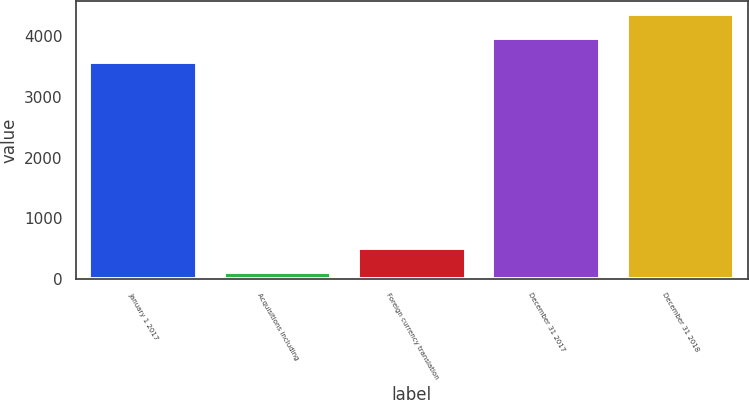<chart> <loc_0><loc_0><loc_500><loc_500><bar_chart><fcel>January 1 2017<fcel>Acquisitions including<fcel>Foreign currency translation<fcel>December 31 2017<fcel>December 31 2018<nl><fcel>3572<fcel>112<fcel>507.8<fcel>3967.8<fcel>4363.6<nl></chart> 